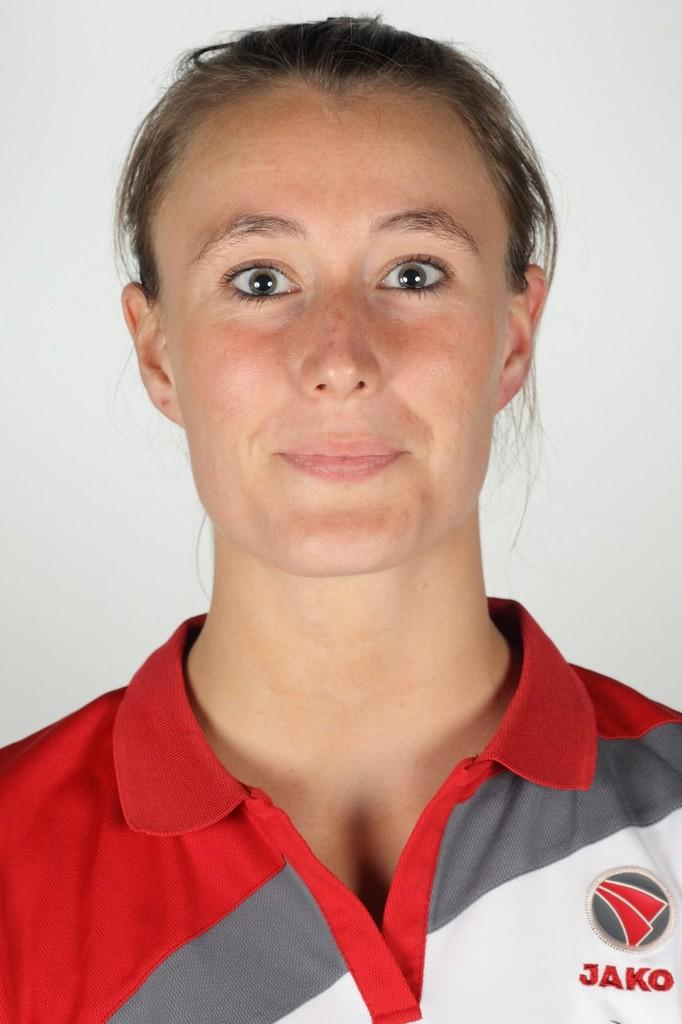<image>
Relay a brief, clear account of the picture shown. a lady that is wearing a shirt that says Jako on it 